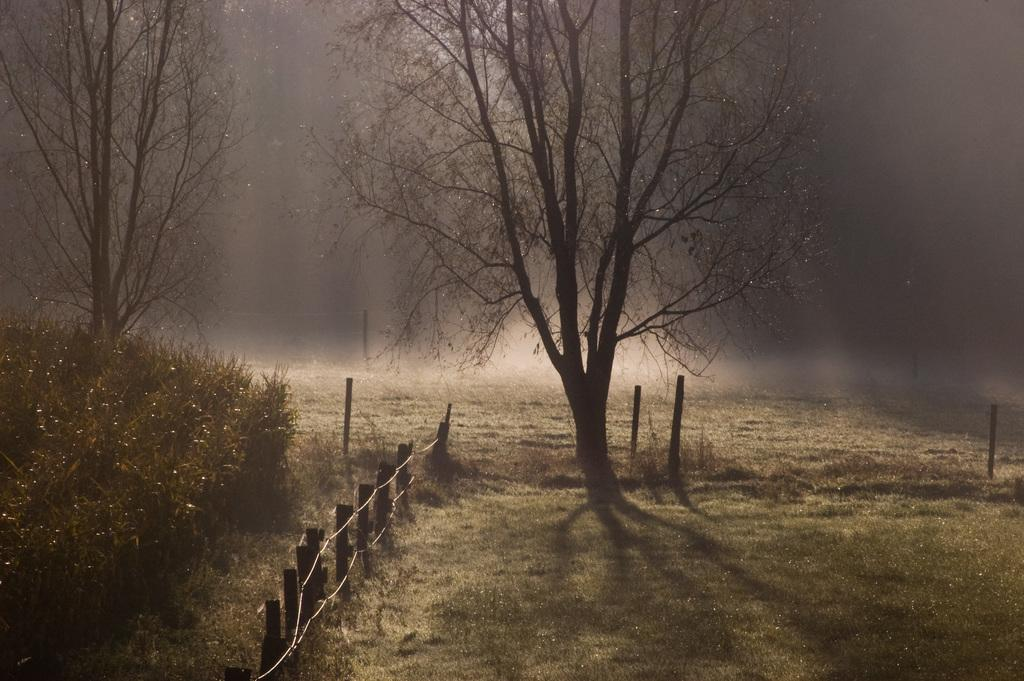What type of vegetation can be seen in the image? There are plants and trees in the image. What type of structure is present in the image? There is fencing in the image. Are there any vertical structures in the image? Yes, there are poles in the image. How would you describe the lighting in the image? The background of the image appears to be dark. Can you see a donkey in the image? No, there is no donkey present in the image. What type of art is displayed on the trees in the image? There is no art displayed on the trees in the image; it features plants and trees in their natural state. 